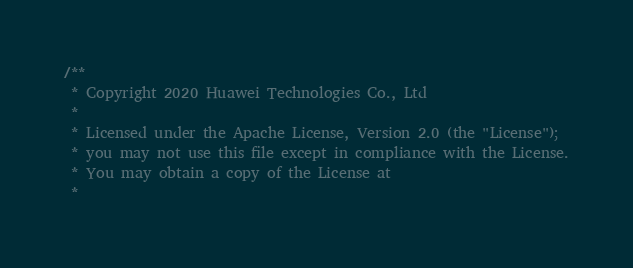<code> <loc_0><loc_0><loc_500><loc_500><_Cuda_>/**
 * Copyright 2020 Huawei Technologies Co., Ltd
 *
 * Licensed under the Apache License, Version 2.0 (the "License");
 * you may not use this file except in compliance with the License.
 * You may obtain a copy of the License at
 *</code> 